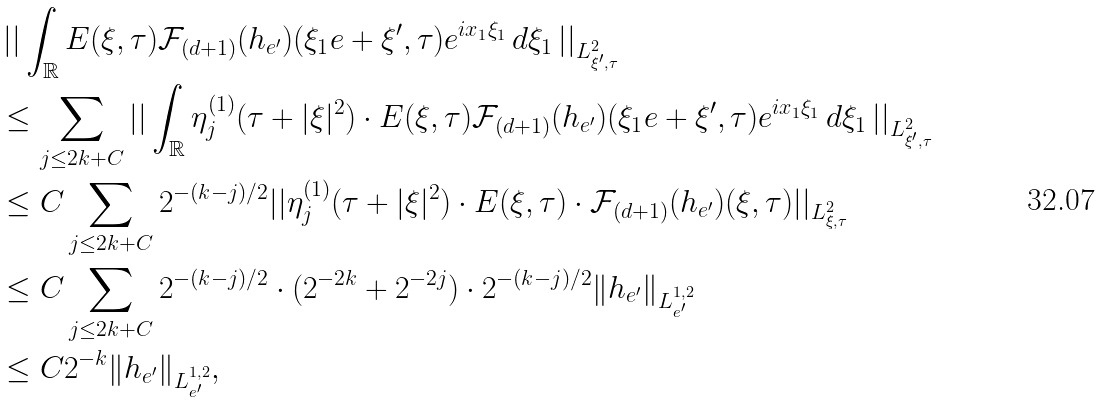<formula> <loc_0><loc_0><loc_500><loc_500>& \left | \right | \int _ { \mathbb { R } } E ( \xi , \tau ) \mathcal { F } _ { ( d + 1 ) } ( h _ { e ^ { \prime } } ) ( \xi _ { 1 } e + \xi ^ { \prime } , \tau ) e ^ { i x _ { 1 } \xi _ { 1 } } \, d \xi _ { 1 } \left | \right | _ { L ^ { 2 } _ { \xi ^ { \prime } , \tau } } \\ & \leq \sum _ { j \leq 2 k + C } \left | \right | \int _ { \mathbb { R } } \eta _ { j } ^ { ( 1 ) } ( \tau + | \xi | ^ { 2 } ) \cdot E ( \xi , \tau ) \mathcal { F } _ { ( d + 1 ) } ( h _ { e ^ { \prime } } ) ( \xi _ { 1 } e + \xi ^ { \prime } , \tau ) e ^ { i x _ { 1 } \xi _ { 1 } } \, d \xi _ { 1 } \left | \right | _ { L ^ { 2 } _ { \xi ^ { \prime } , \tau } } \\ & \leq C \sum _ { j \leq 2 k + C } 2 ^ { - ( k - j ) / 2 } | | \eta _ { j } ^ { ( 1 ) } ( \tau + | \xi | ^ { 2 } ) \cdot E ( \xi , \tau ) \cdot \mathcal { F } _ { ( d + 1 ) } ( h _ { e ^ { \prime } } ) ( \xi , \tau ) | | _ { L ^ { 2 } _ { \xi , \tau } } \\ & \leq C \sum _ { j \leq 2 k + C } 2 ^ { - ( k - j ) / 2 } \cdot ( 2 ^ { - 2 k } + 2 ^ { - 2 j } ) \cdot 2 ^ { - ( k - j ) / 2 } \| h _ { e ^ { \prime } } \| _ { L ^ { 1 , 2 } _ { e ^ { \prime } } } \\ & \leq C 2 ^ { - k } \| h _ { e ^ { \prime } } \| _ { L ^ { 1 , 2 } _ { e ^ { \prime } } } ,</formula> 